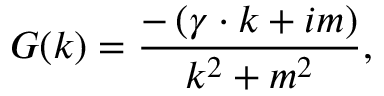Convert formula to latex. <formula><loc_0><loc_0><loc_500><loc_500>G ( k ) = \frac { - \left ( \gamma \cdot k + i m \right ) } { k ^ { 2 } + m ^ { 2 } } ,</formula> 